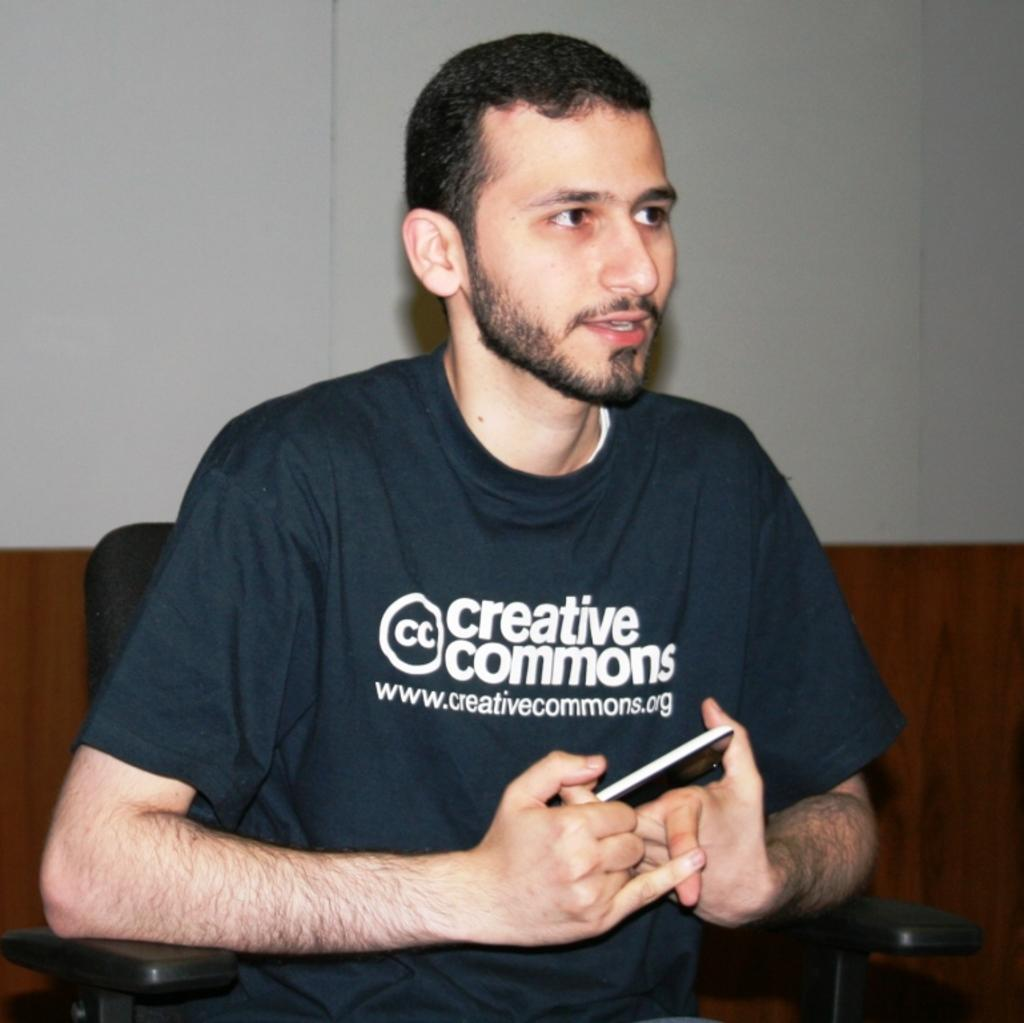Who is present in the image? There is a man in the image. What is the man holding in the image? The man is holding a phone. What is the man doing with the phone? The man is talking on the phone. What can be seen in the background of the image? There is a wall in the background of the image. What type of pencil is the man using to write a note in the image? There is no pencil or note-writing activity present in the image; the man is talking on the phone. 